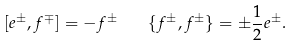<formula> <loc_0><loc_0><loc_500><loc_500>[ e ^ { \pm } , f ^ { \mp } ] = - f ^ { \pm } \quad \{ f ^ { \pm } , f ^ { \pm } \} = \pm \frac { 1 } { 2 } e ^ { \pm } .</formula> 